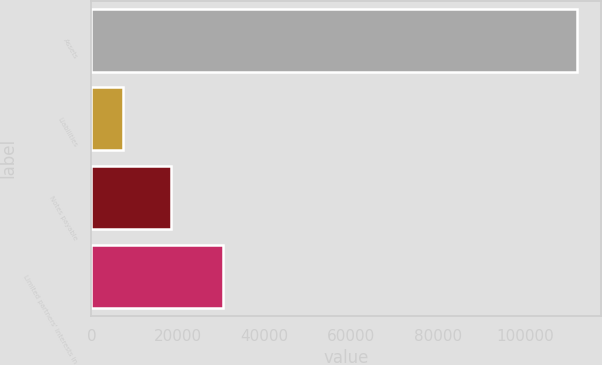Convert chart to OTSL. <chart><loc_0><loc_0><loc_500><loc_500><bar_chart><fcel>Assets<fcel>Liabilities<fcel>Notes payable<fcel>Limited partners' interests in<nl><fcel>112085<fcel>7309<fcel>18432<fcel>30280<nl></chart> 